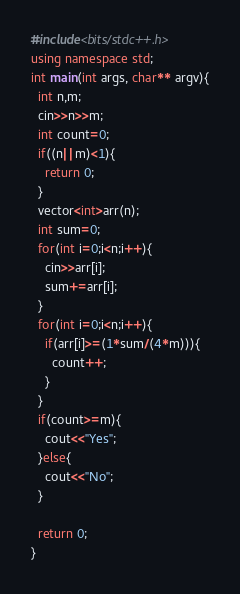Convert code to text. <code><loc_0><loc_0><loc_500><loc_500><_C++_>#include<bits/stdc++.h>
using namespace std;
int main(int args, char** argv){
  int n,m;
  cin>>n>>m;
  int count=0;
  if((n||m)<1){
    return 0;
  }
  vector<int>arr(n);
  int sum=0;
  for(int i=0;i<n;i++){
    cin>>arr[i];
    sum+=arr[i];
  }
  for(int i=0;i<n;i++){
    if(arr[i]>=(1*sum/(4*m))){
      count++;
    }
  }
  if(count>=m){
    cout<<"Yes";
  }else{
    cout<<"No";
  }
  
  return 0;
}
</code> 